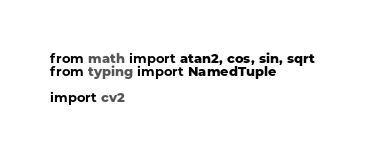<code> <loc_0><loc_0><loc_500><loc_500><_Python_>from math import atan2, cos, sin, sqrt
from typing import NamedTuple

import cv2</code> 